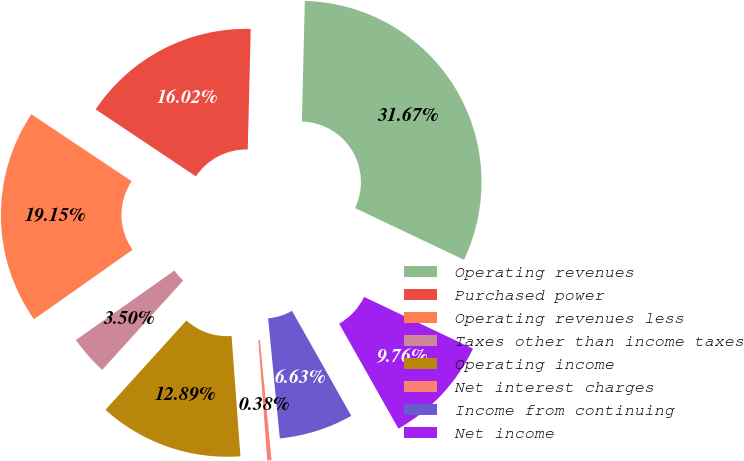Convert chart. <chart><loc_0><loc_0><loc_500><loc_500><pie_chart><fcel>Operating revenues<fcel>Purchased power<fcel>Operating revenues less<fcel>Taxes other than income taxes<fcel>Operating income<fcel>Net interest charges<fcel>Income from continuing<fcel>Net income<nl><fcel>31.67%<fcel>16.02%<fcel>19.15%<fcel>3.5%<fcel>12.89%<fcel>0.38%<fcel>6.63%<fcel>9.76%<nl></chart> 